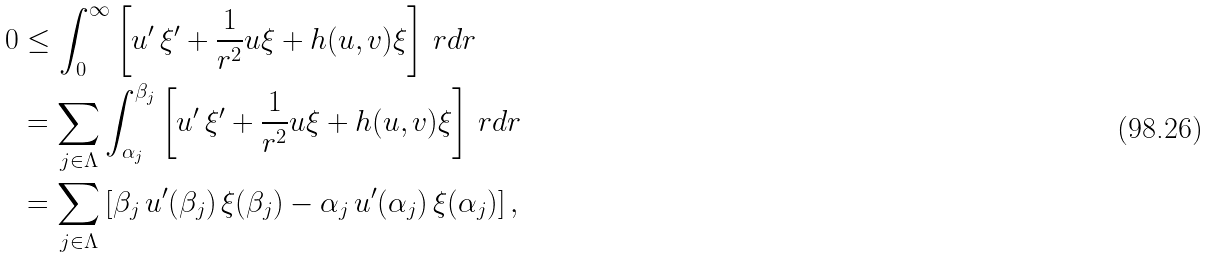Convert formula to latex. <formula><loc_0><loc_0><loc_500><loc_500>0 & \leq \int _ { 0 } ^ { \infty } \left [ u ^ { \prime } \, \xi ^ { \prime } + \frac { 1 } { r ^ { 2 } } u \xi + h ( u , v ) \xi \right ] \, r d r \\ & = \sum _ { j \in \Lambda } \int _ { \alpha _ { j } } ^ { \beta _ { j } } \left [ u ^ { \prime } \, \xi ^ { \prime } + \frac { 1 } { r ^ { 2 } } u \xi + h ( u , v ) \xi \right ] \, r d r \\ & = \sum _ { j \in \Lambda } \left [ \beta _ { j } \, u ^ { \prime } ( \beta _ { j } ) \, \xi ( \beta _ { j } ) - \alpha _ { j } \, u ^ { \prime } ( \alpha _ { j } ) \, \xi ( \alpha _ { j } ) \right ] ,</formula> 